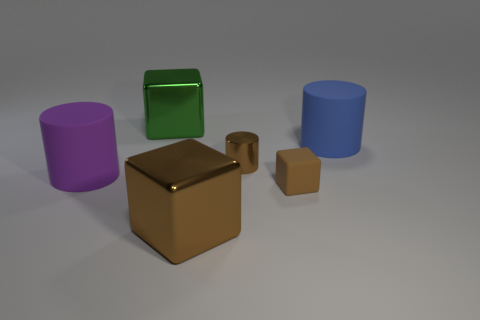Add 3 purple spheres. How many objects exist? 9 Add 4 shiny spheres. How many shiny spheres exist? 4 Subtract 0 yellow cylinders. How many objects are left? 6 Subtract all green shiny cubes. Subtract all large cubes. How many objects are left? 3 Add 1 brown blocks. How many brown blocks are left? 3 